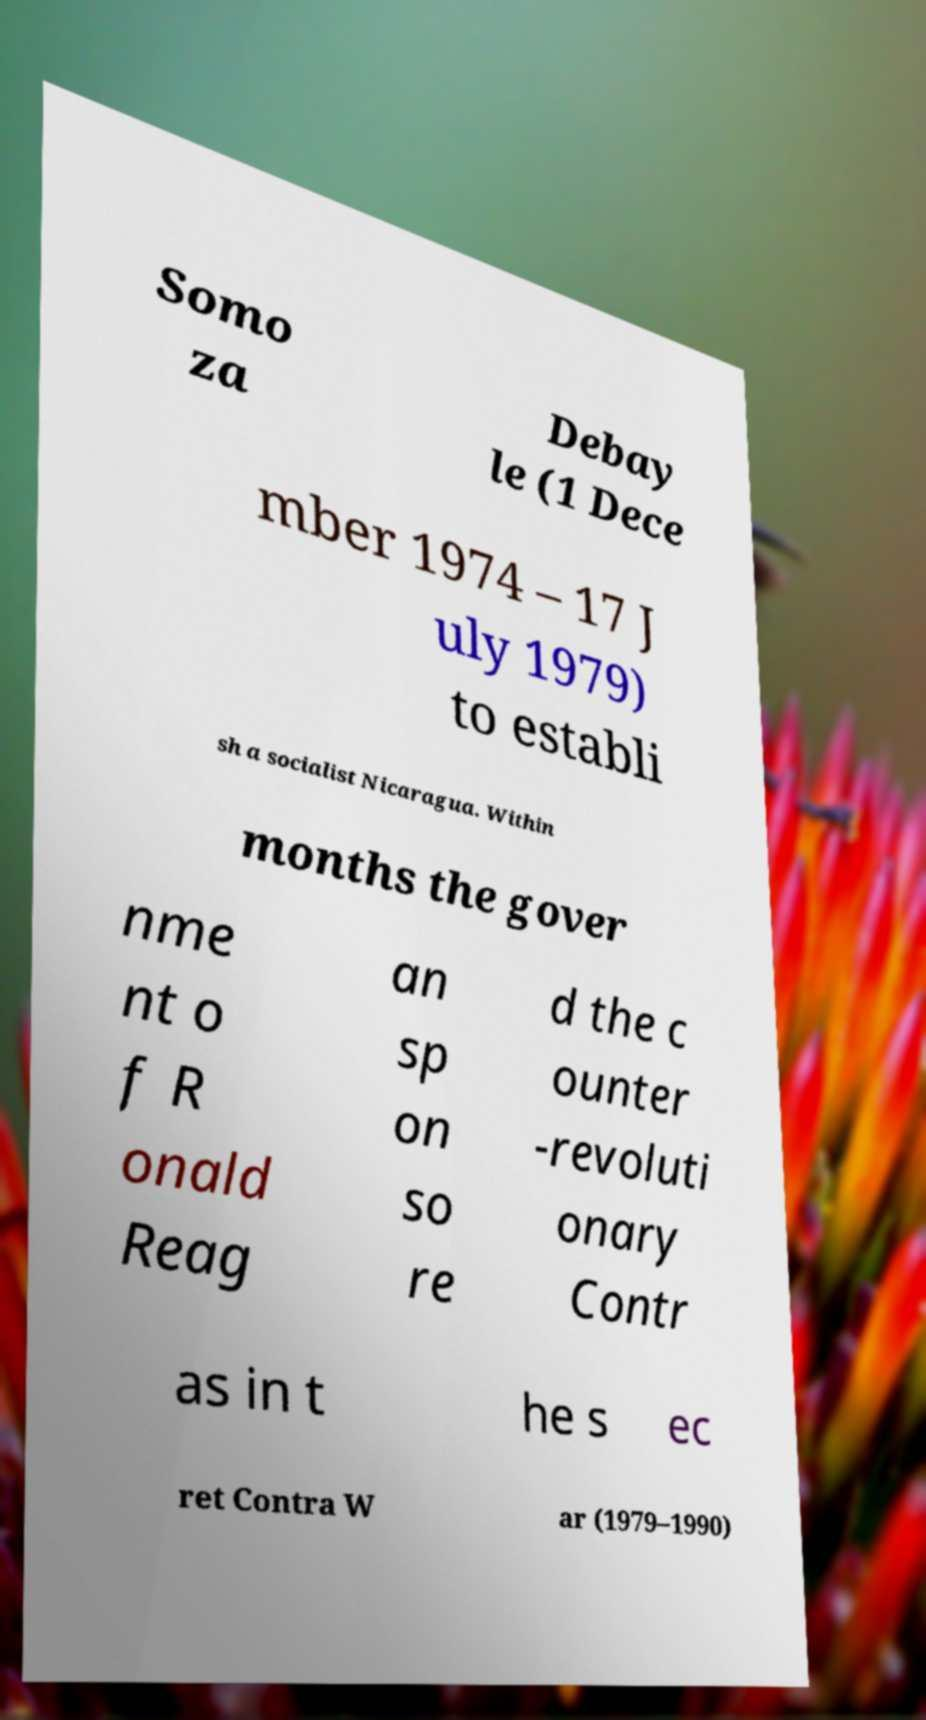There's text embedded in this image that I need extracted. Can you transcribe it verbatim? Somo za Debay le (1 Dece mber 1974 – 17 J uly 1979) to establi sh a socialist Nicaragua. Within months the gover nme nt o f R onald Reag an sp on so re d the c ounter -revoluti onary Contr as in t he s ec ret Contra W ar (1979–1990) 